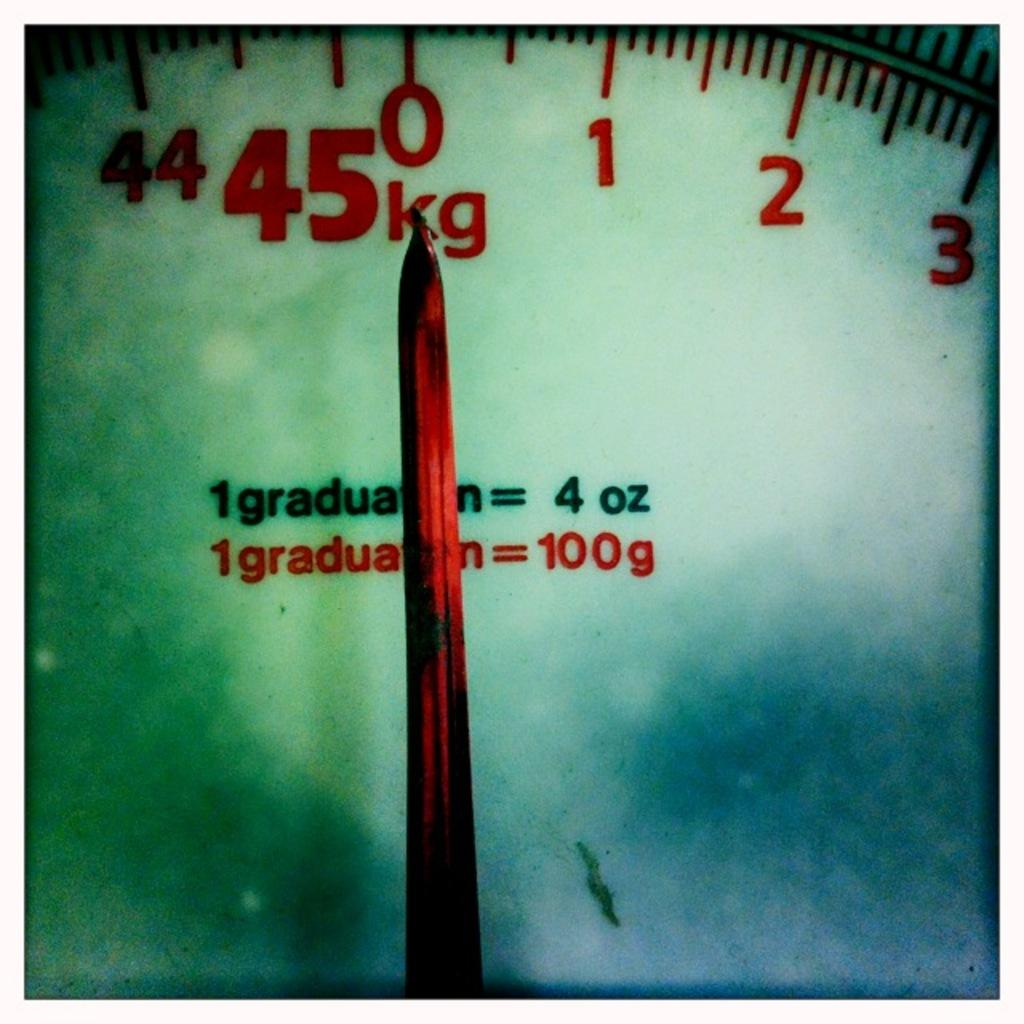<image>
Share a concise interpretation of the image provided. A scale with a close up of it pointing to 0 and it goes up to 45kg. 